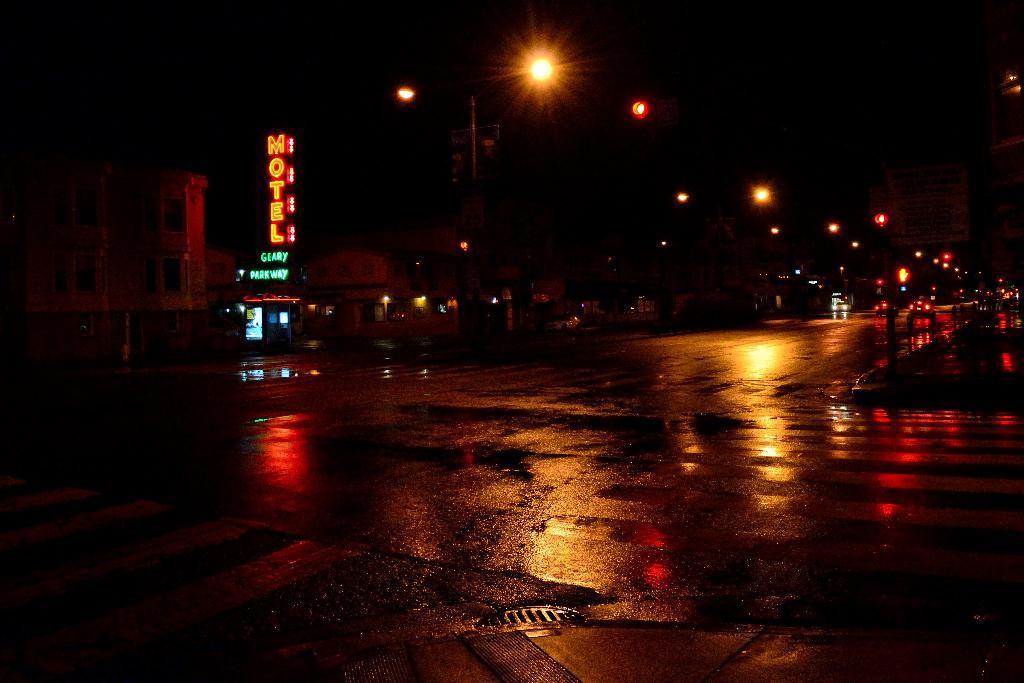Please provide a concise description of this image. This image is taken at night time. In this image we can see there are buildings, street lights and a few vehicles on the road. The background is dark. 